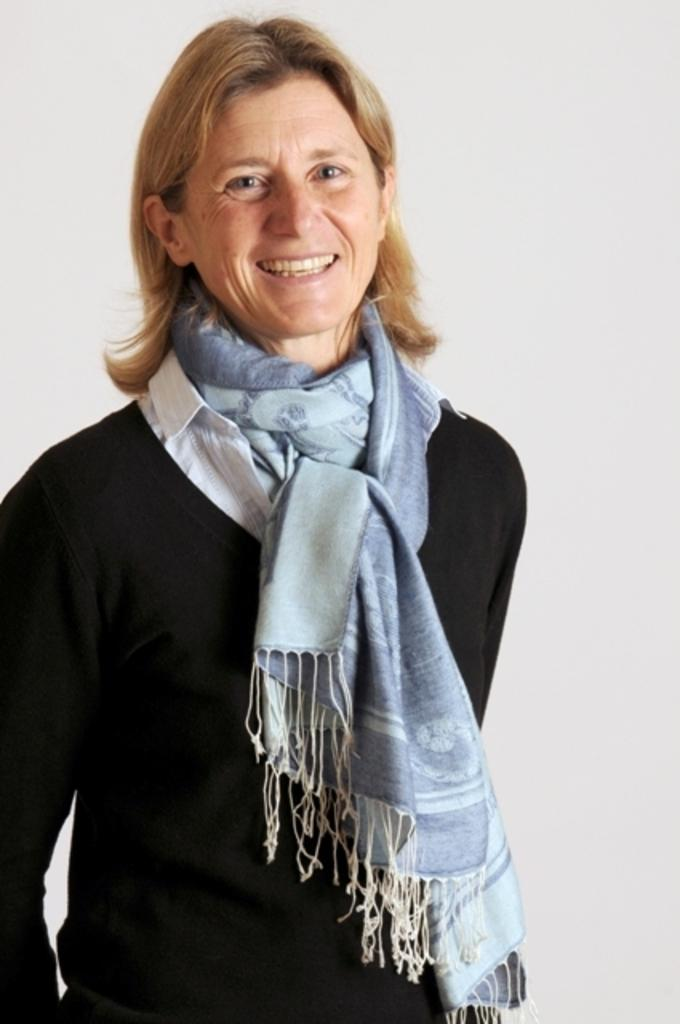What is the main subject of the image? The main subject of the image is a woman. What is the woman wearing in the image? The woman is wearing a scarf. What is the woman's posture in the image? The woman is standing. What type of cherry is the woman holding in the image? There is no cherry present in the image, and therefore no such activity can be observed. How many brothers does the woman have in the image? There is no information about the woman's brothers in the image. 